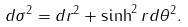Convert formula to latex. <formula><loc_0><loc_0><loc_500><loc_500>d \sigma ^ { 2 } = d r ^ { 2 } + \sinh ^ { 2 } r d \theta ^ { 2 } .</formula> 